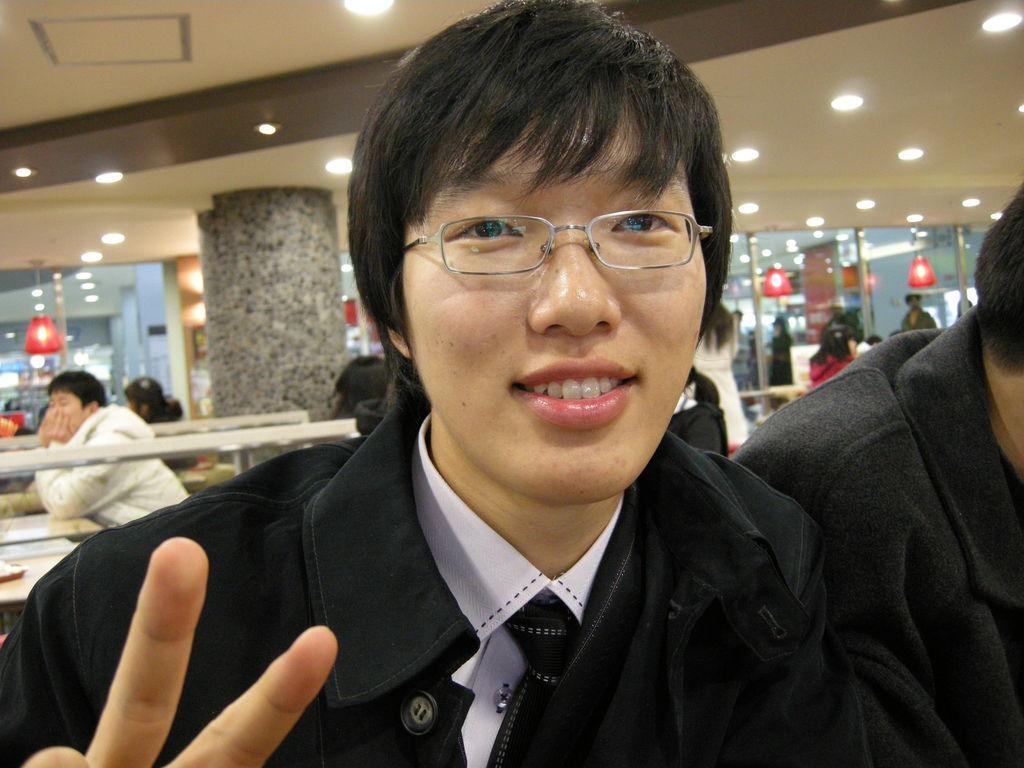Can you describe this image briefly? This picture describes about group of people, in the middle of the image we can see a man, he wore spectacles and he is smiling, in the background we can find few lights and glasses. 